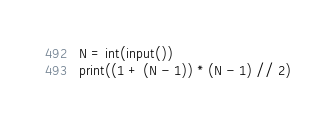Convert code to text. <code><loc_0><loc_0><loc_500><loc_500><_Python_>N = int(input())
print((1 + (N - 1)) * (N - 1) // 2)
</code> 